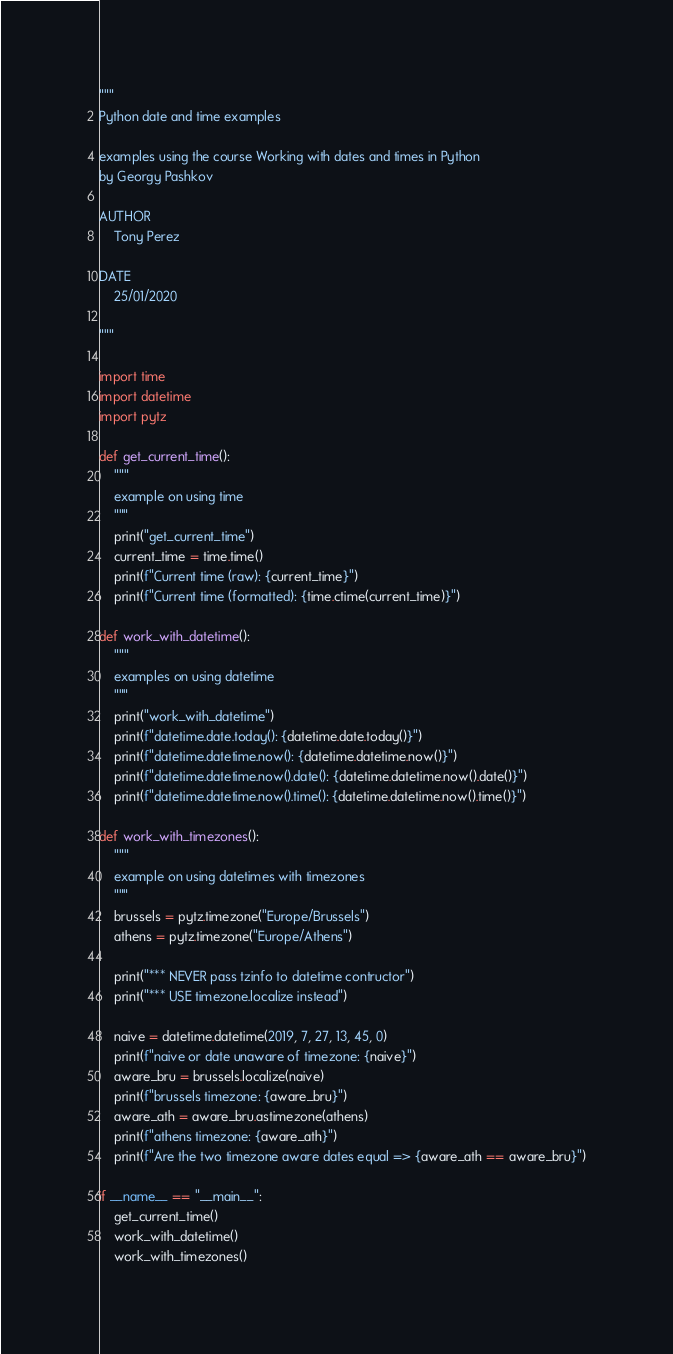Convert code to text. <code><loc_0><loc_0><loc_500><loc_500><_Python_>"""
Python date and time examples

examples using the course Working with dates and times in Python
by Georgy Pashkov

AUTHOR
    Tony Perez

DATE
    25/01/2020

"""

import time
import datetime
import pytz

def get_current_time():
    """
    example on using time
    """
    print("get_current_time")
    current_time = time.time()
    print(f"Current time (raw): {current_time}")
    print(f"Current time (formatted): {time.ctime(current_time)}")

def work_with_datetime():
    """
    examples on using datetime
    """
    print("work_with_datetime")
    print(f"datetime.date.today(): {datetime.date.today()}")
    print(f"datetime.datetime.now(): {datetime.datetime.now()}")
    print(f"datetime.datetime.now().date(): {datetime.datetime.now().date()}")
    print(f"datetime.datetime.now().time(): {datetime.datetime.now().time()}")

def work_with_timezones():
    """
    example on using datetimes with timezones
    """
    brussels = pytz.timezone("Europe/Brussels")
    athens = pytz.timezone("Europe/Athens")

    print("*** NEVER pass tzinfo to datetime contructor")
    print("*** USE timezone.localize instead")

    naive = datetime.datetime(2019, 7, 27, 13, 45, 0)
    print(f"naive or date unaware of timezone: {naive}")
    aware_bru = brussels.localize(naive)
    print(f"brussels timezone: {aware_bru}")
    aware_ath = aware_bru.astimezone(athens)
    print(f"athens timezone: {aware_ath}")
    print(f"Are the two timezone aware dates equal => {aware_ath == aware_bru}")

if __name__ == "__main__":
    get_current_time()
    work_with_datetime()
    work_with_timezones()
</code> 